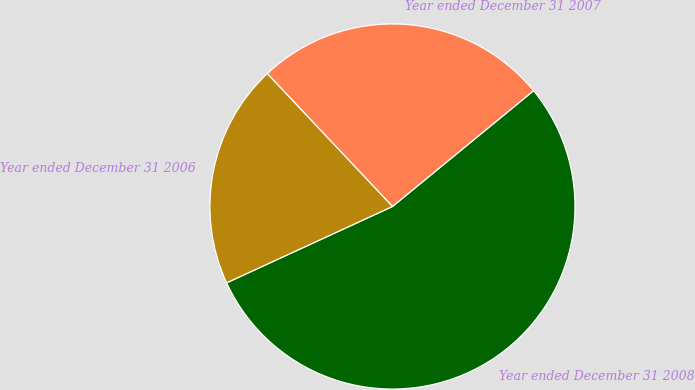Convert chart. <chart><loc_0><loc_0><loc_500><loc_500><pie_chart><fcel>Year ended December 31 2008<fcel>Year ended December 31 2007<fcel>Year ended December 31 2006<nl><fcel>54.07%<fcel>26.09%<fcel>19.84%<nl></chart> 